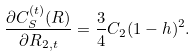<formula> <loc_0><loc_0><loc_500><loc_500>\frac { \partial C _ { S } ^ { ( t ) } ( R ) } { \partial R _ { 2 , t } } = \frac { 3 } { 4 } C _ { 2 } ( 1 - h ) ^ { 2 } .</formula> 